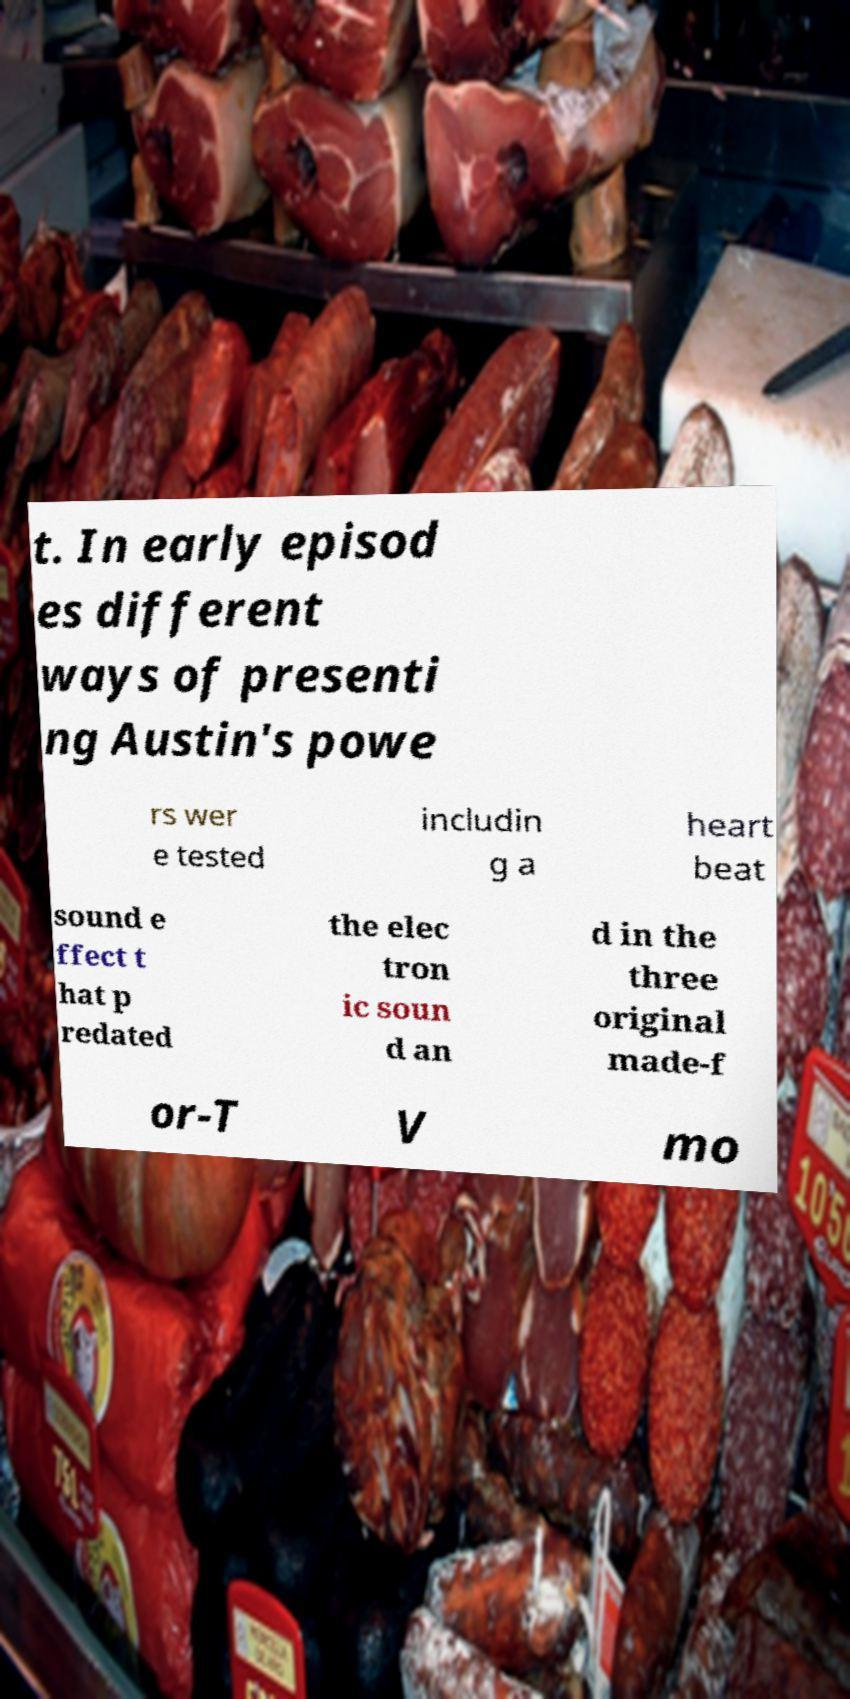For documentation purposes, I need the text within this image transcribed. Could you provide that? t. In early episod es different ways of presenti ng Austin's powe rs wer e tested includin g a heart beat sound e ffect t hat p redated the elec tron ic soun d an d in the three original made-f or-T V mo 